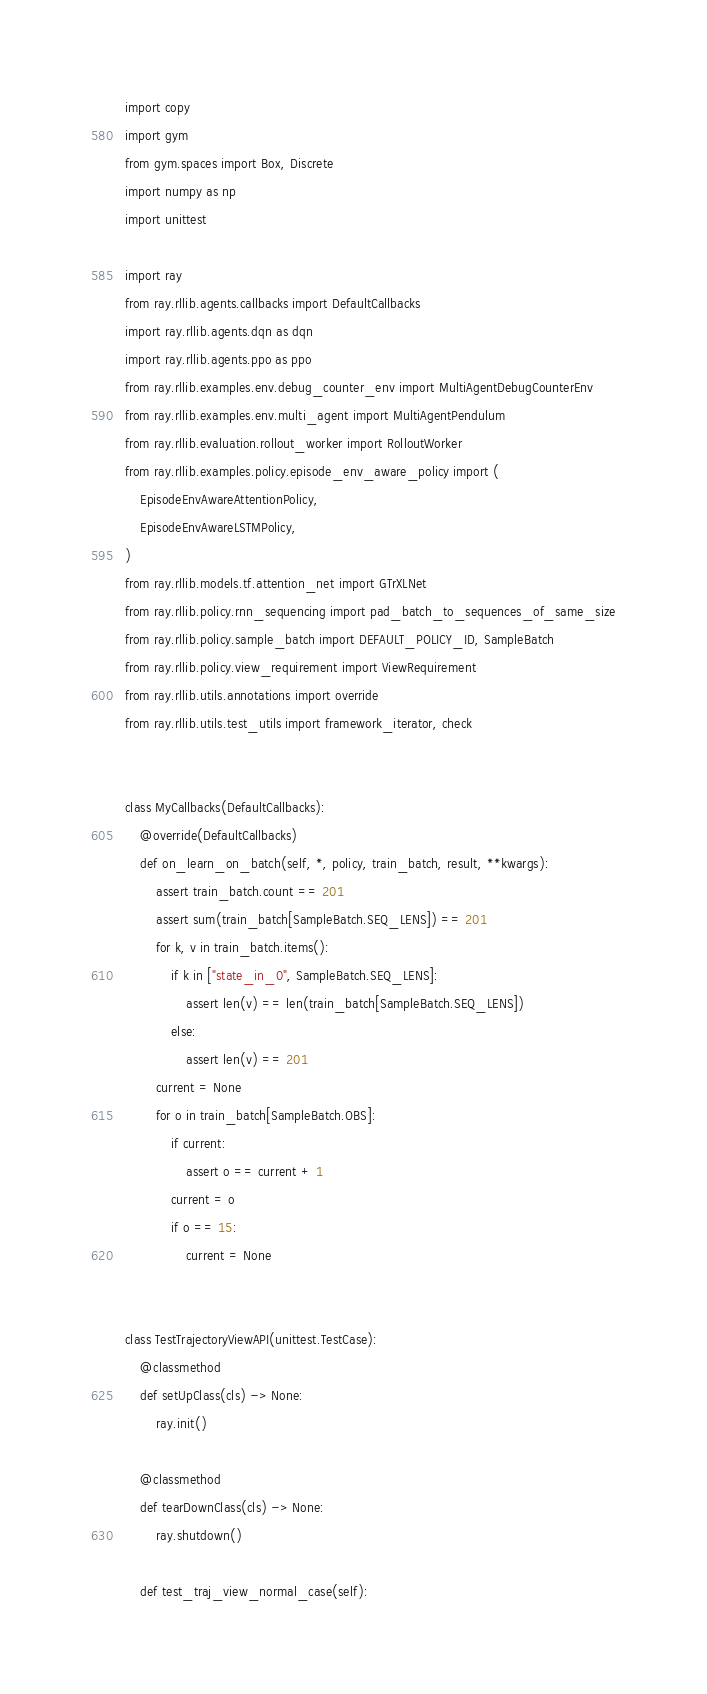<code> <loc_0><loc_0><loc_500><loc_500><_Python_>import copy
import gym
from gym.spaces import Box, Discrete
import numpy as np
import unittest

import ray
from ray.rllib.agents.callbacks import DefaultCallbacks
import ray.rllib.agents.dqn as dqn
import ray.rllib.agents.ppo as ppo
from ray.rllib.examples.env.debug_counter_env import MultiAgentDebugCounterEnv
from ray.rllib.examples.env.multi_agent import MultiAgentPendulum
from ray.rllib.evaluation.rollout_worker import RolloutWorker
from ray.rllib.examples.policy.episode_env_aware_policy import (
    EpisodeEnvAwareAttentionPolicy,
    EpisodeEnvAwareLSTMPolicy,
)
from ray.rllib.models.tf.attention_net import GTrXLNet
from ray.rllib.policy.rnn_sequencing import pad_batch_to_sequences_of_same_size
from ray.rllib.policy.sample_batch import DEFAULT_POLICY_ID, SampleBatch
from ray.rllib.policy.view_requirement import ViewRequirement
from ray.rllib.utils.annotations import override
from ray.rllib.utils.test_utils import framework_iterator, check


class MyCallbacks(DefaultCallbacks):
    @override(DefaultCallbacks)
    def on_learn_on_batch(self, *, policy, train_batch, result, **kwargs):
        assert train_batch.count == 201
        assert sum(train_batch[SampleBatch.SEQ_LENS]) == 201
        for k, v in train_batch.items():
            if k in ["state_in_0", SampleBatch.SEQ_LENS]:
                assert len(v) == len(train_batch[SampleBatch.SEQ_LENS])
            else:
                assert len(v) == 201
        current = None
        for o in train_batch[SampleBatch.OBS]:
            if current:
                assert o == current + 1
            current = o
            if o == 15:
                current = None


class TestTrajectoryViewAPI(unittest.TestCase):
    @classmethod
    def setUpClass(cls) -> None:
        ray.init()

    @classmethod
    def tearDownClass(cls) -> None:
        ray.shutdown()

    def test_traj_view_normal_case(self):</code> 